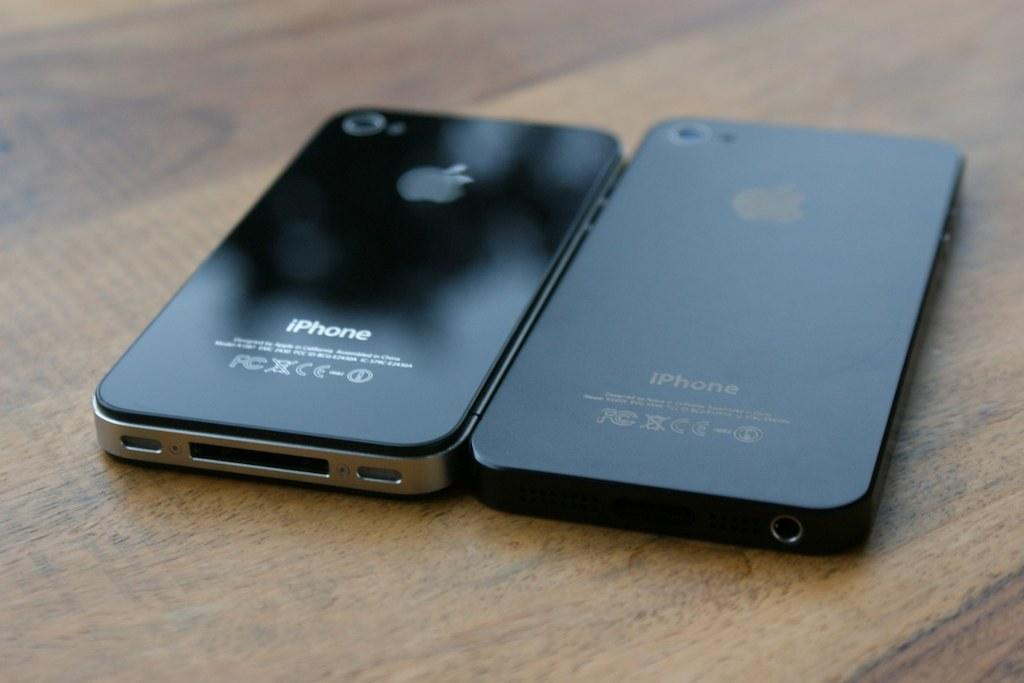<image>
Create a compact narrative representing the image presented. Two black iphone cellphones side by side on a wood table 